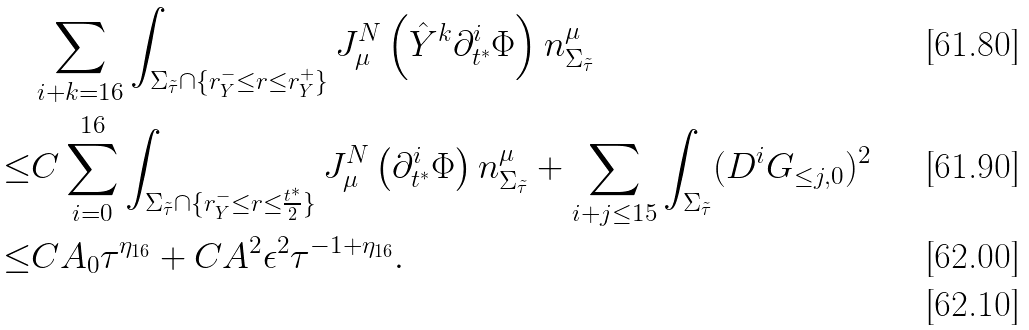<formula> <loc_0><loc_0><loc_500><loc_500>& \sum _ { i + k = 1 6 } \int _ { \Sigma _ { \tilde { \tau } } \cap \{ r ^ { - } _ { Y } \leq r \leq r ^ { + } _ { Y } \} } J ^ { N } _ { \mu } \left ( \hat { Y } ^ { k } \partial _ { t ^ { * } } ^ { i } \Phi \right ) n ^ { \mu } _ { \Sigma _ { \tilde { \tau } } } \\ \leq & C \sum _ { i = 0 } ^ { 1 6 } \int _ { \Sigma _ { \tilde { \tau } } \cap \{ r ^ { - } _ { Y } \leq r \leq \frac { t ^ { * } } { 2 } \} } J ^ { N } _ { \mu } \left ( \partial _ { t ^ { * } } ^ { i } \Phi \right ) n ^ { \mu } _ { \Sigma _ { \tilde { \tau } } } + \sum _ { i + j \leq 1 5 } \int _ { \Sigma _ { \tilde { \tau } } } ( D ^ { i } G _ { \leq j , 0 } ) ^ { 2 } \\ \leq & C A _ { 0 } \tau ^ { \eta _ { 1 6 } } + C A ^ { 2 } \epsilon ^ { 2 } \tau ^ { - 1 + \eta _ { 1 6 } } . \\</formula> 